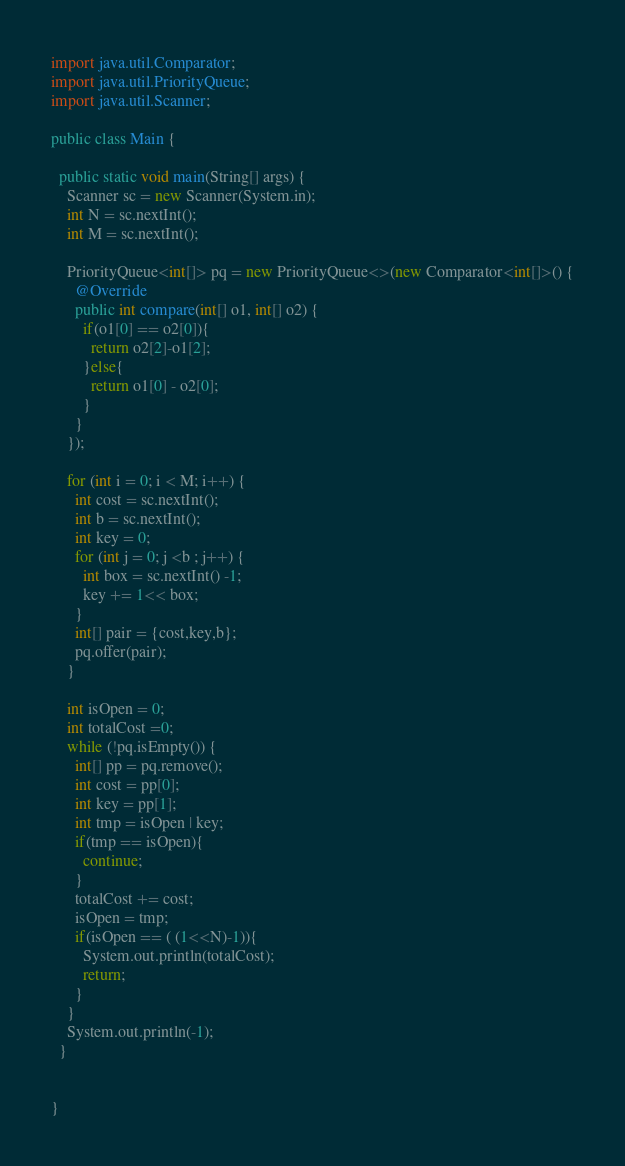<code> <loc_0><loc_0><loc_500><loc_500><_Java_>import java.util.Comparator;
import java.util.PriorityQueue;
import java.util.Scanner;

public class Main {

  public static void main(String[] args) {
    Scanner sc = new Scanner(System.in);
    int N = sc.nextInt();
    int M = sc.nextInt();

    PriorityQueue<int[]> pq = new PriorityQueue<>(new Comparator<int[]>() {
      @Override
      public int compare(int[] o1, int[] o2) {
        if(o1[0] == o2[0]){
          return o2[2]-o1[2];
        }else{
          return o1[0] - o2[0];
        }
      }
    });

    for (int i = 0; i < M; i++) {
      int cost = sc.nextInt();
      int b = sc.nextInt();
      int key = 0;
      for (int j = 0; j <b ; j++) {
        int box = sc.nextInt() -1;
        key += 1<< box;
      }
      int[] pair = {cost,key,b};
      pq.offer(pair);
    }

    int isOpen = 0;
    int totalCost =0;
    while (!pq.isEmpty()) {
      int[] pp = pq.remove();
      int cost = pp[0];
      int key = pp[1];
      int tmp = isOpen | key;
      if(tmp == isOpen){
        continue;
      }
      totalCost += cost;
      isOpen = tmp;
      if(isOpen == ( (1<<N)-1)){
        System.out.println(totalCost);
        return;
      }
    }
    System.out.println(-1);
  }


}
</code> 